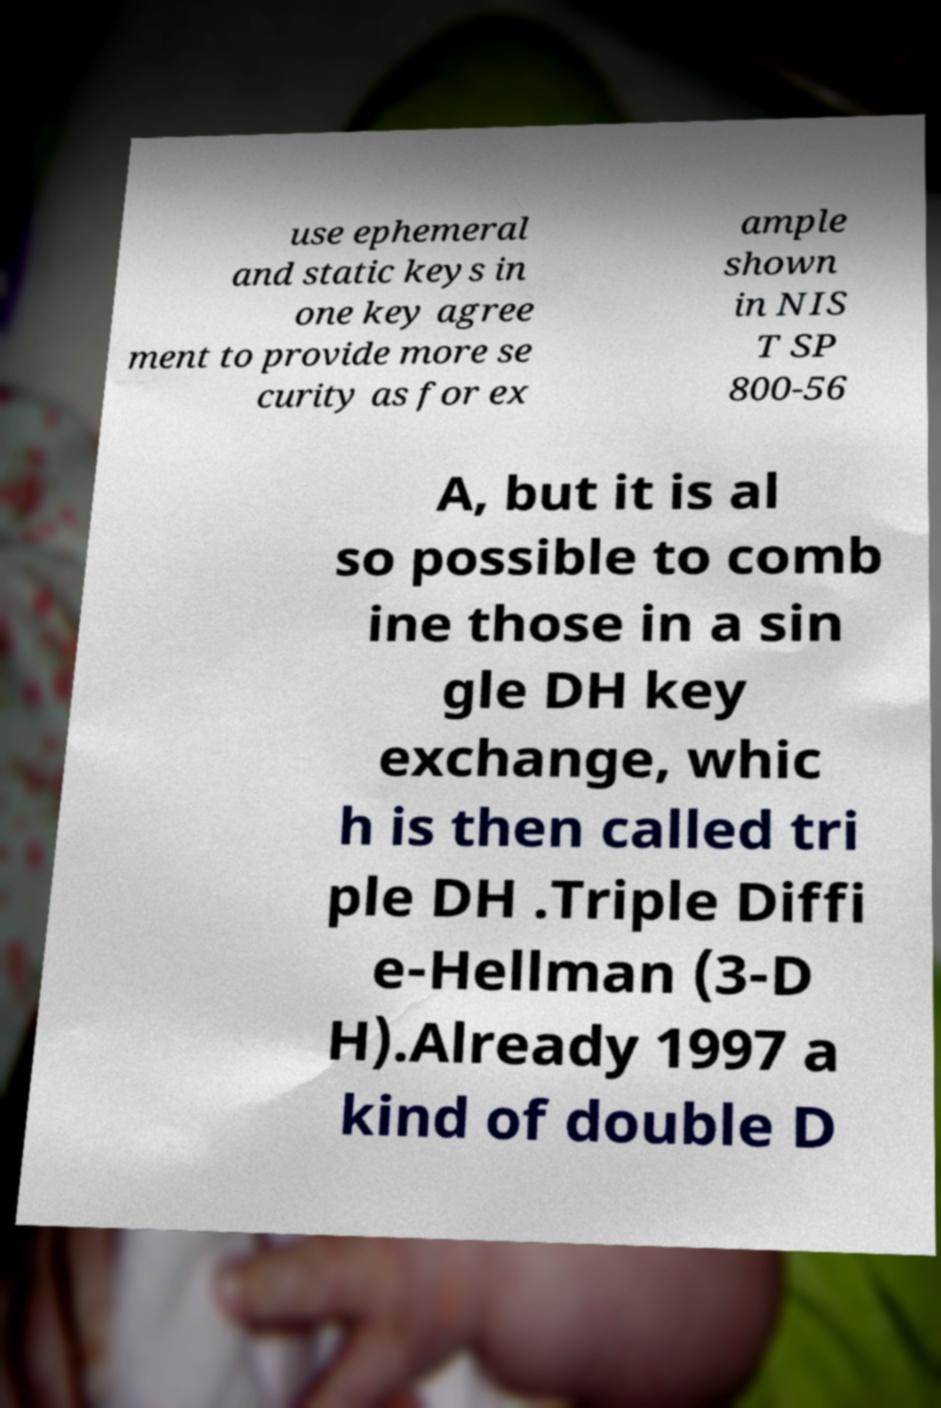Can you read and provide the text displayed in the image?This photo seems to have some interesting text. Can you extract and type it out for me? use ephemeral and static keys in one key agree ment to provide more se curity as for ex ample shown in NIS T SP 800-56 A, but it is al so possible to comb ine those in a sin gle DH key exchange, whic h is then called tri ple DH .Triple Diffi e-Hellman (3-D H).Already 1997 a kind of double D 